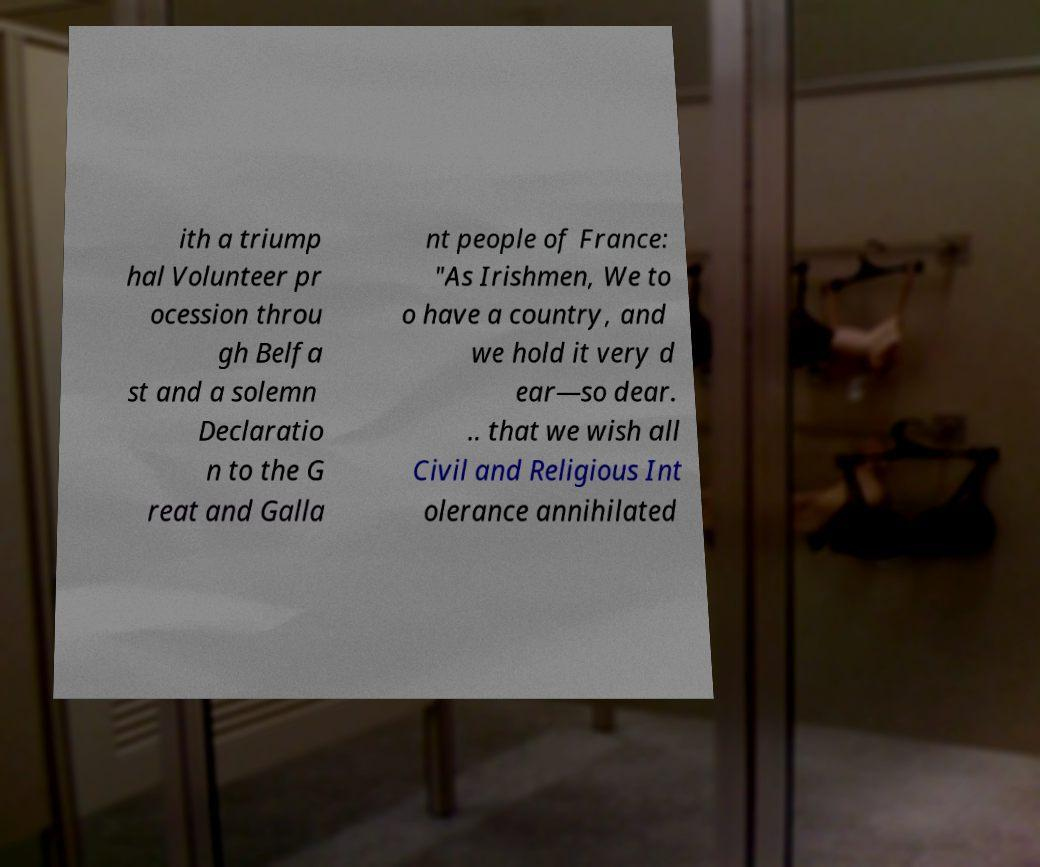There's text embedded in this image that I need extracted. Can you transcribe it verbatim? ith a triump hal Volunteer pr ocession throu gh Belfa st and a solemn Declaratio n to the G reat and Galla nt people of France: "As Irishmen, We to o have a country, and we hold it very d ear—so dear. .. that we wish all Civil and Religious Int olerance annihilated 